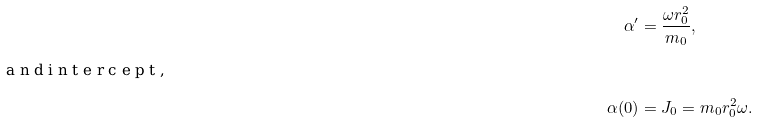<formula> <loc_0><loc_0><loc_500><loc_500>\alpha ^ { \prime } & = \frac { \omega r _ { 0 } ^ { 2 } } { m _ { 0 } } , \intertext { a n d i n t e r c e p t , } \alpha ( 0 ) & = J _ { 0 } = m _ { 0 } r _ { 0 } ^ { 2 } \omega .</formula> 